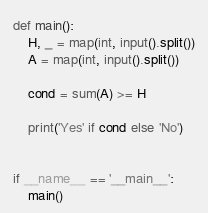Convert code to text. <code><loc_0><loc_0><loc_500><loc_500><_Python_>def main():
    H, _ = map(int, input().split())
    A = map(int, input().split())

    cond = sum(A) >= H

    print('Yes' if cond else 'No')


if __name__ == '__main__':
    main()
</code> 